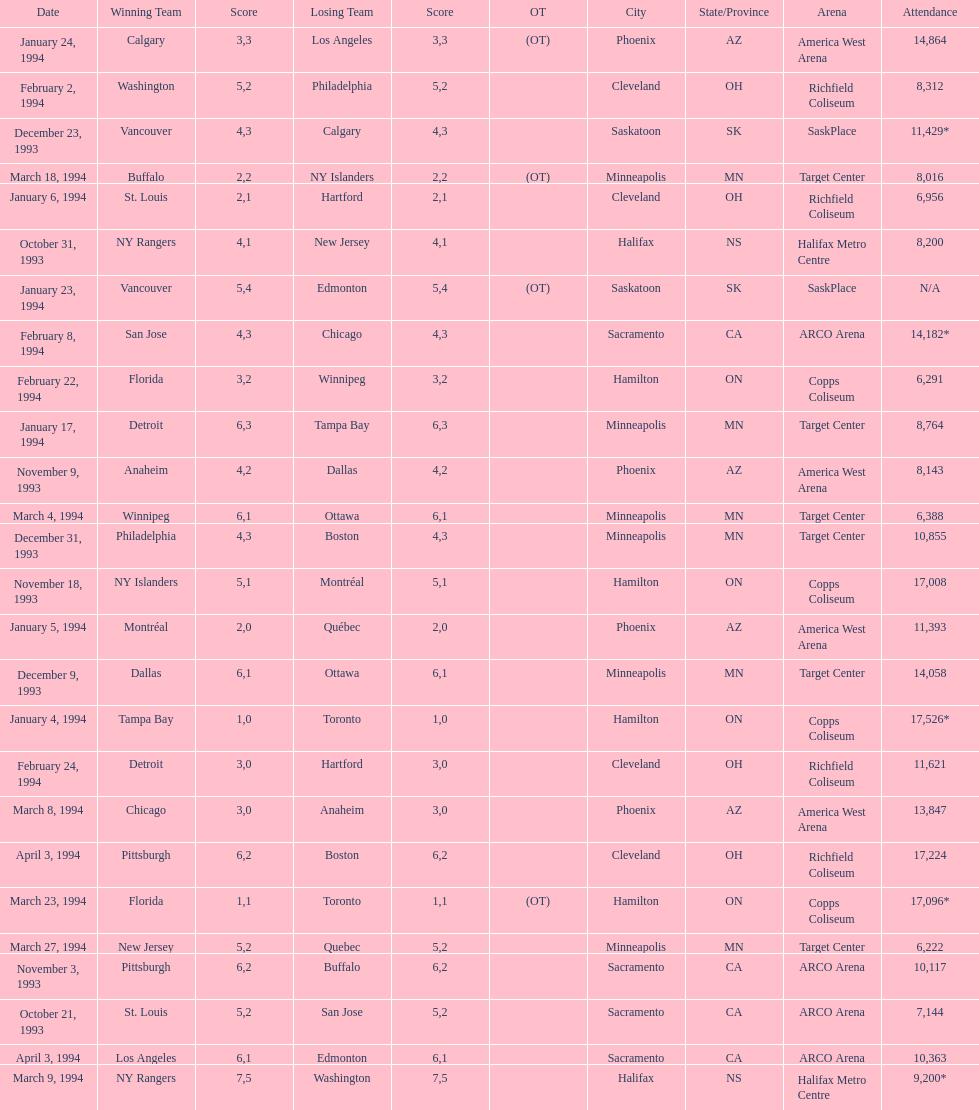How many more people attended the november 18, 1993 games than the november 9th game? 8865. 